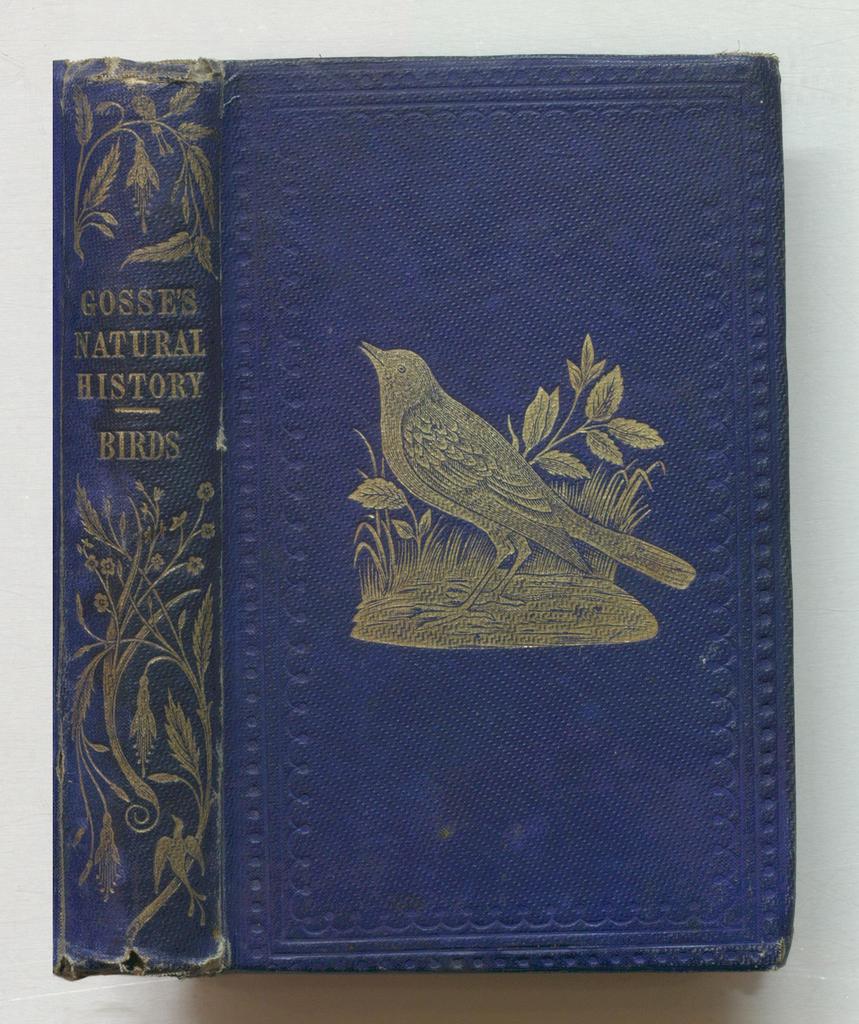What is on the cover?
Your answer should be compact. Answering does not require reading text in the image. What is the name of this book?
Your answer should be very brief. Gosses natural history. 